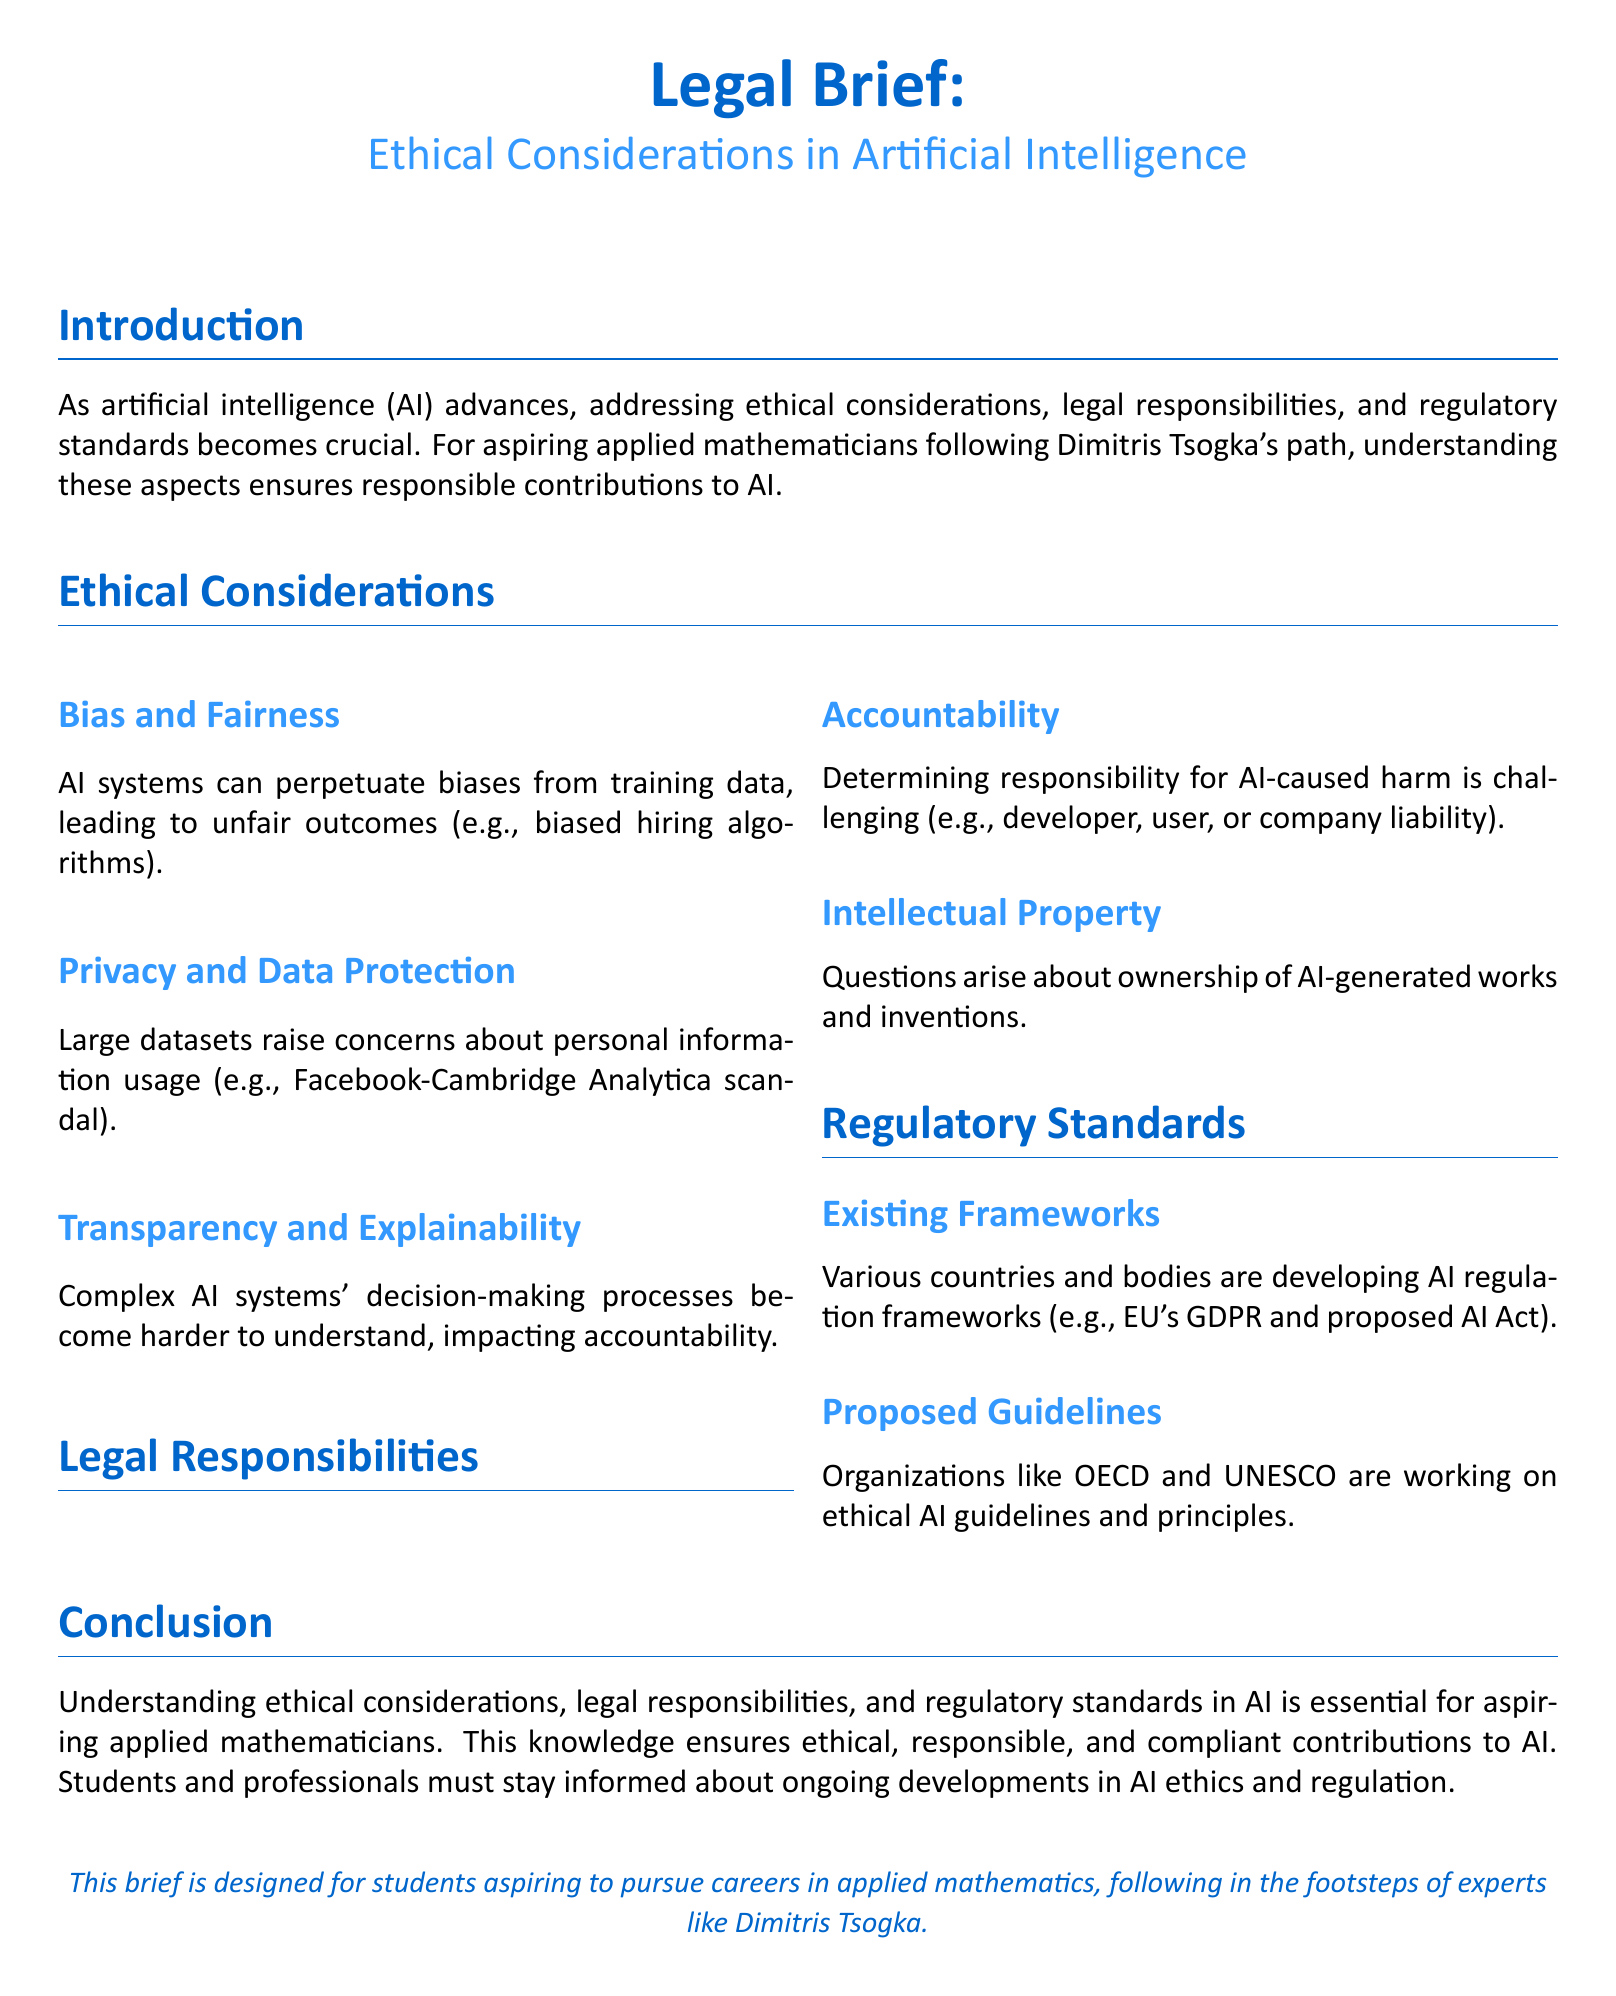What is the main topic of the legal brief? The main topic is stated in the title of the document, which addresses ethical considerations in artificial intelligence.
Answer: Ethical Considerations in Artificial Intelligence Who is the audience for this legal brief? The brief explicitly mentions its intended audience, which are students aspiring to pursue careers in applied mathematics.
Answer: Students aspiring to pursue careers in applied mathematics What are two ethical considerations mentioned in the brief? The brief lists ethical considerations, specifically under the section titled "Ethical Considerations", which includes bias and fairness, and privacy and data protection.
Answer: Bias and fairness, Privacy and data protection What is one proposed guideline organization mentioned in the document? The document lists organizations working on ethical AI guidelines; one specific organization is the OECD.
Answer: OECD What does accountability refer to in the context of legal responsibilities? Accountability in this document relates to determining who is responsible for AI-caused harm, a central theme in the legal responsibilities section.
Answer: Responsibility for AI-caused harm What regulatory framework from the EU is mentioned? The brief refers to existing frameworks, specifically highlighting regulations from the European Union, such as GDPR.
Answer: GDPR What color is used for the main title of the brief? The main title's color is defined in the document, which is indicated as the 'maincolor' RGB specification.
Answer: Maincolor What is required for aspiring applied mathematicians according to the conclusion? The conclusion emphasizes the importance of understanding certain aspects related to AI, such as ethical considerations, legal responsibilities, and regulatory standards.
Answer: Understanding ethical considerations, legal responsibilities, and regulatory standards in AI 